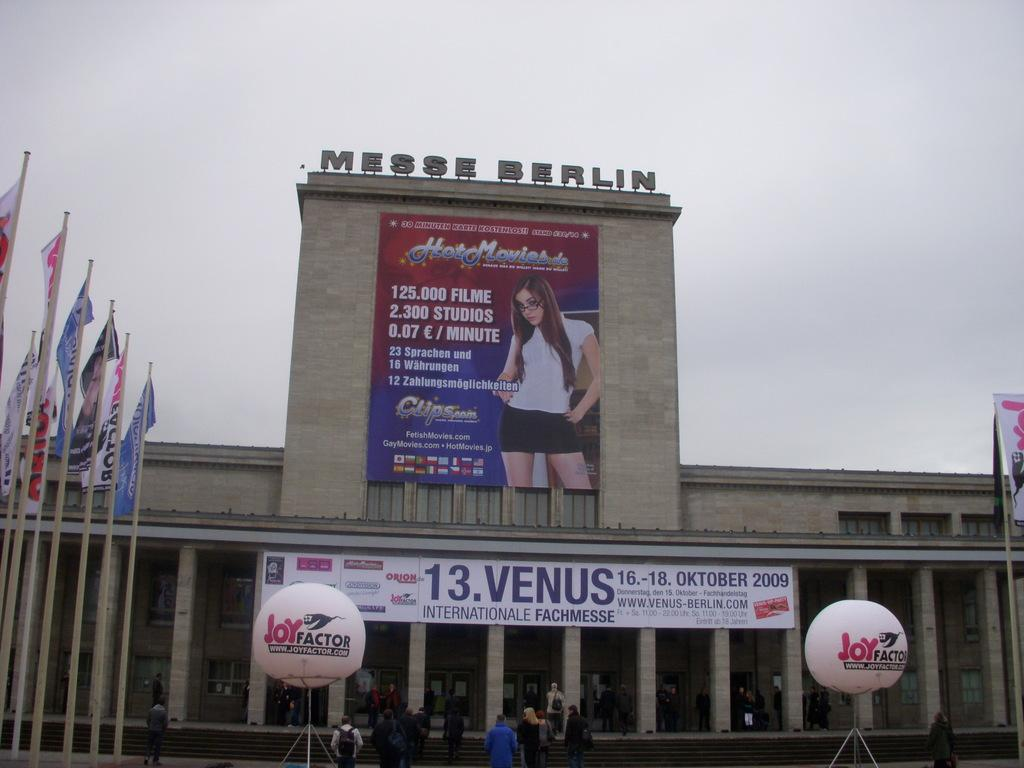<image>
Offer a succinct explanation of the picture presented. A large stone building has a sign with a woman and says 13. Venus. 